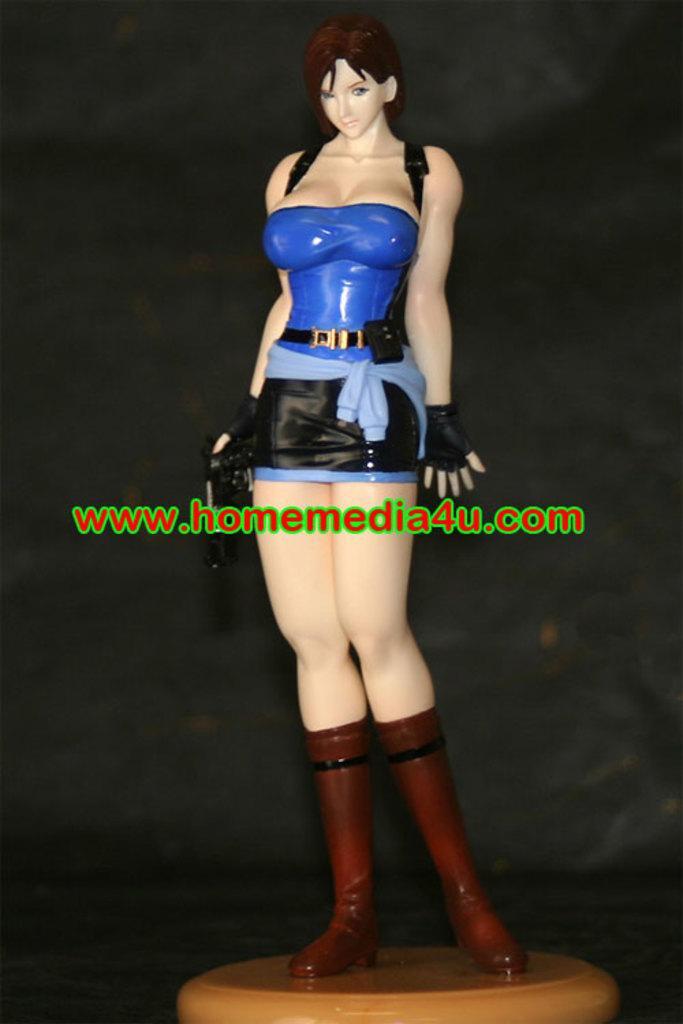In one or two sentences, can you explain what this image depicts? In this picture I can observe an animation of a woman in the middle of the picture. I can observe text in the middle of the picture. The background is dark. 